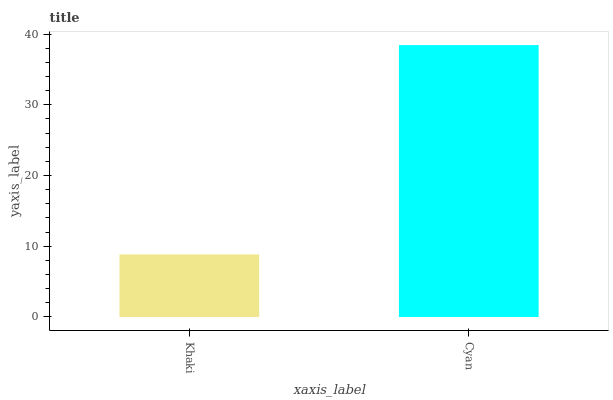Is Khaki the minimum?
Answer yes or no. Yes. Is Cyan the maximum?
Answer yes or no. Yes. Is Cyan the minimum?
Answer yes or no. No. Is Cyan greater than Khaki?
Answer yes or no. Yes. Is Khaki less than Cyan?
Answer yes or no. Yes. Is Khaki greater than Cyan?
Answer yes or no. No. Is Cyan less than Khaki?
Answer yes or no. No. Is Cyan the high median?
Answer yes or no. Yes. Is Khaki the low median?
Answer yes or no. Yes. Is Khaki the high median?
Answer yes or no. No. Is Cyan the low median?
Answer yes or no. No. 